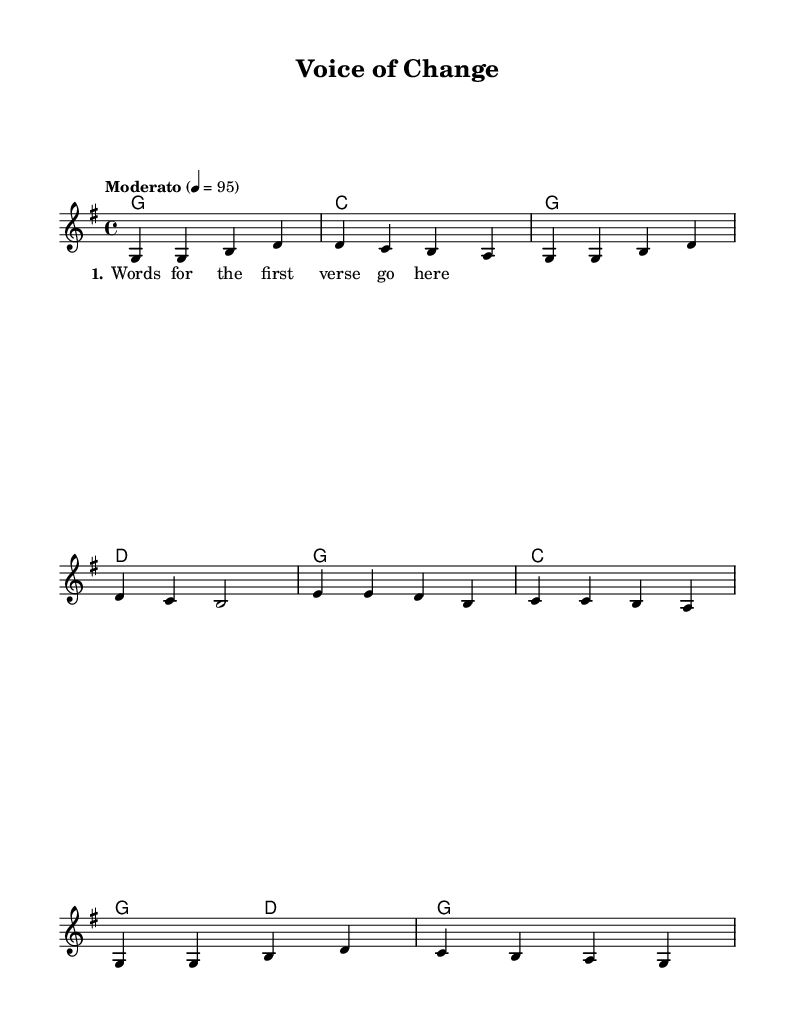What is the key signature of this music? The key signature is G major, which has one sharp (F#). This can be identified by locating the key signature section at the beginning of the staff where the F# is indicated.
Answer: G major What is the time signature of this music? The time signature is 4/4, indicated at the beginning of the sheet music after the key signature. This means there are four beats in a measure, and the quarter note gets one beat.
Answer: 4/4 What is the tempo marking of this piece? The tempo marking is Moderato, with a metronome indication of 95 beats per minute. It's found at the beginning of the score, indicating a moderate speed for the performance.
Answer: Moderato How many measures are in the melody section? The melody section contains eight measures. This can be counted by observing the bar lines that separate each measure throughout the melody part.
Answer: Eight What is the first chord in the harmony section? The first chord in the harmony section is G major, as indicated by the chord symbol placed above the melody at the start of the score.
Answer: G Which stanza is represented in the lyrics section? The lyrics section represents the first stanza, as indicated by the labeling within the lyric mode. This labeling shows the organizing structure of the text for the music.
Answer: 1 How many different chords are used in the harmony section? There are four different chords used in the harmony section: G, C, and D as identified in the chord changes. These represent the harmonic structure that accompanies the melody.
Answer: Four 